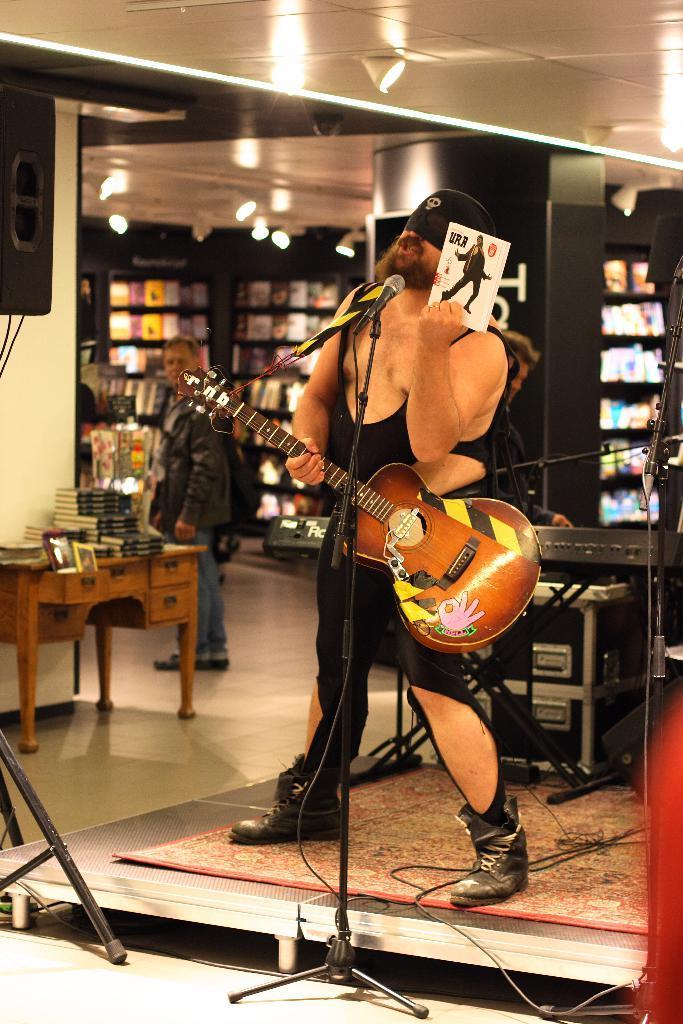Describe this image in one or two sentences. This image is clicked inside a building. There are two men in this image. In the middle the man is standing and singing on the dais, and holding a guitar in his hand. There is a mic and mic stand in front of him. In the background there is a rack in that some books are kept. 